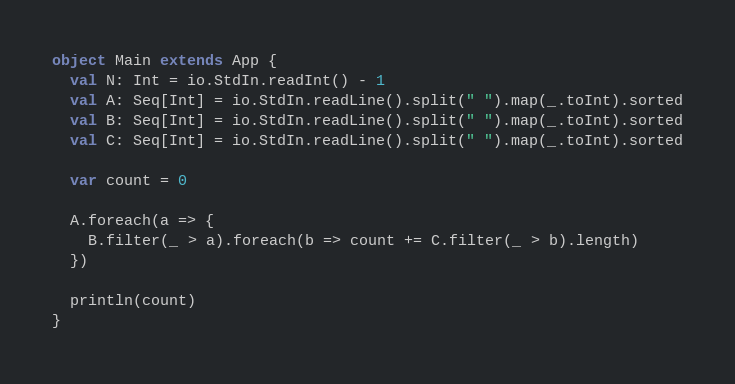Convert code to text. <code><loc_0><loc_0><loc_500><loc_500><_Scala_>object Main extends App {
  val N: Int = io.StdIn.readInt() - 1
  val A: Seq[Int] = io.StdIn.readLine().split(" ").map(_.toInt).sorted
  val B: Seq[Int] = io.StdIn.readLine().split(" ").map(_.toInt).sorted
  val C: Seq[Int] = io.StdIn.readLine().split(" ").map(_.toInt).sorted

  var count = 0

  A.foreach(a => {
    B.filter(_ > a).foreach(b => count += C.filter(_ > b).length)
  })

  println(count)
}</code> 